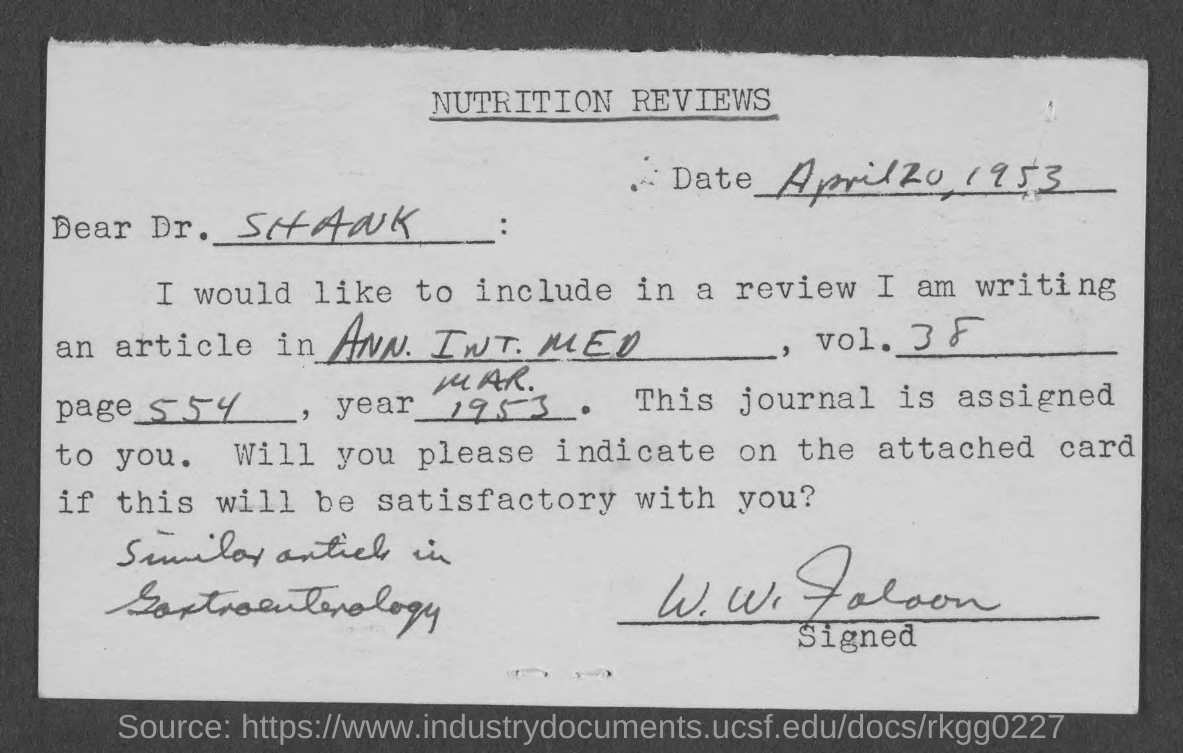Highlight a few significant elements in this photo. The date mentioned in the top paragraph of the document is April 20, 1953. 